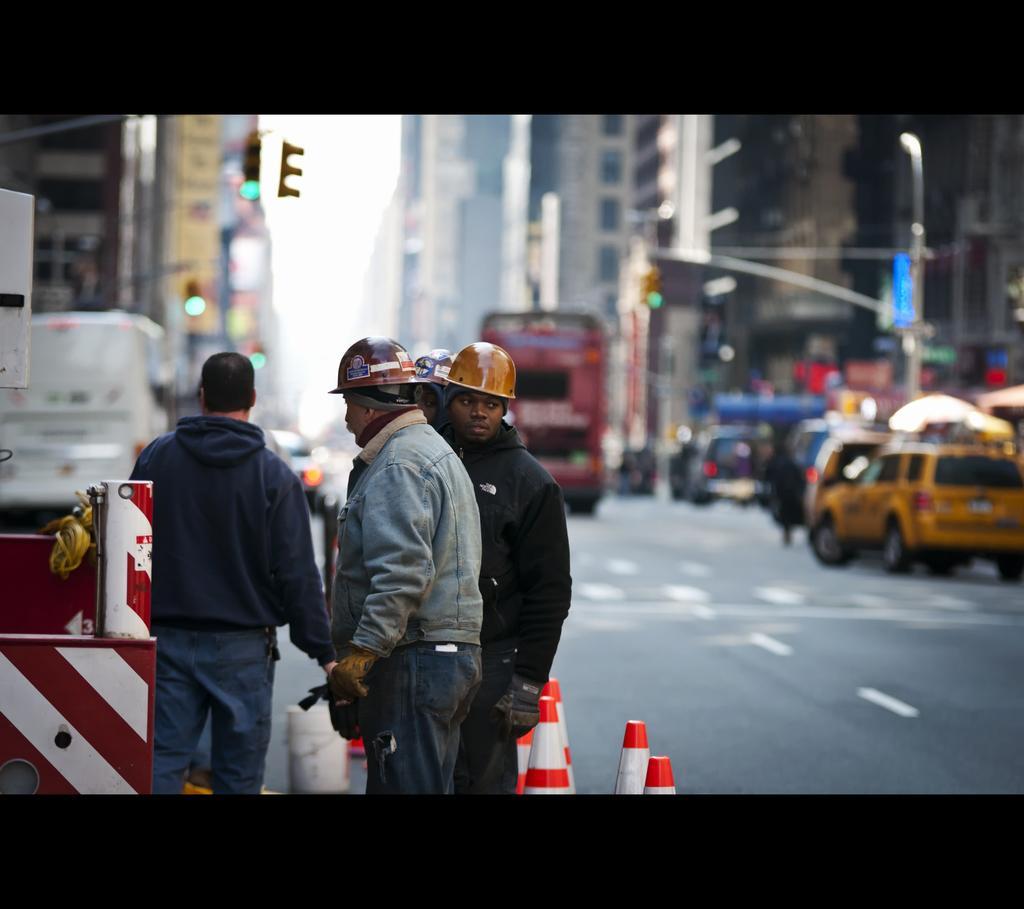Please provide a concise description of this image. In this image in the front there are persons standing and there are stands which are red and white in colour. In the background there are vehicles moving on the road and there are buildings and there are poles. On the left side there is an object which is red and white in colour. 